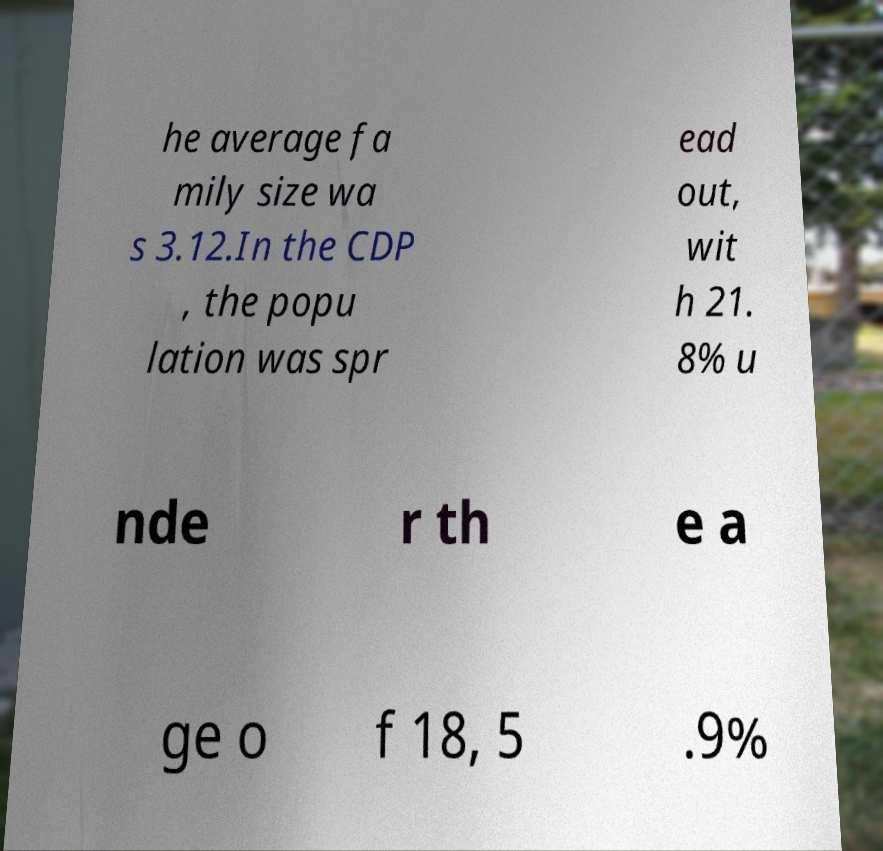There's text embedded in this image that I need extracted. Can you transcribe it verbatim? he average fa mily size wa s 3.12.In the CDP , the popu lation was spr ead out, wit h 21. 8% u nde r th e a ge o f 18, 5 .9% 